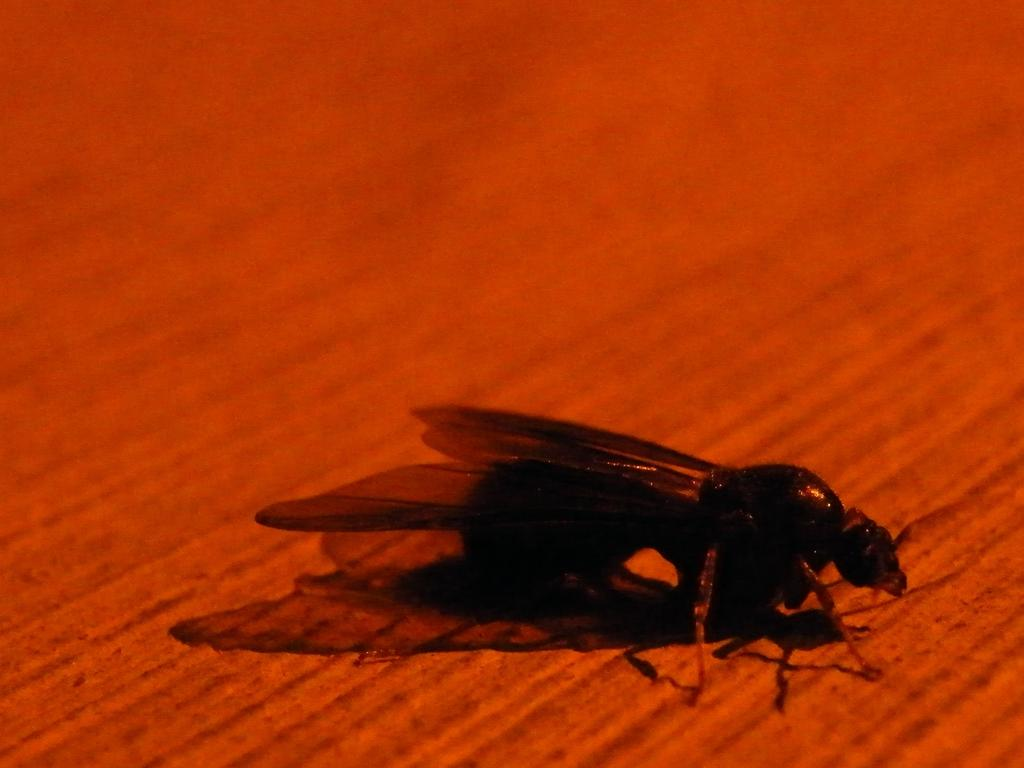What type of creature is present in the image? There is an insect in the image. What specific feature does the insect have? The insect has wings. What is the color of the surface where the insect is located? The insect is on a red surface. How does the insect draw attention to itself in the image? The insect does not draw attention to itself in the image; it is simply present on the red surface. What type of bulb is visible in the image? There is no bulb present in the image. 